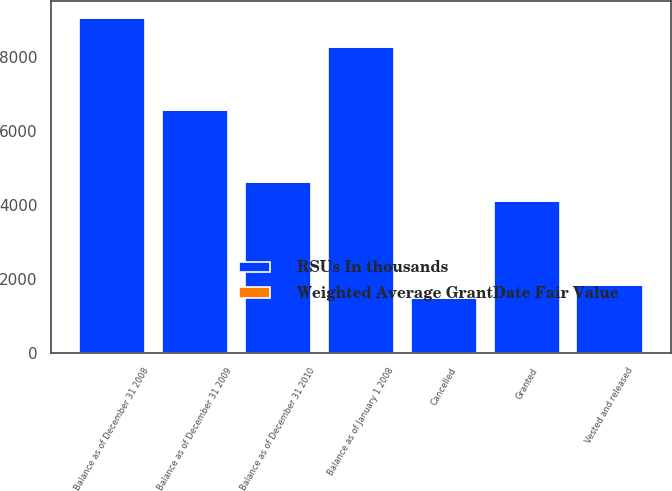<chart> <loc_0><loc_0><loc_500><loc_500><stacked_bar_chart><ecel><fcel>Balance as of January 1 2008<fcel>Granted<fcel>Vested and released<fcel>Cancelled<fcel>Balance as of December 31 2008<fcel>Balance as of December 31 2009<fcel>Balance as of December 31 2010<nl><fcel>RSUs In thousands<fcel>8262<fcel>4123<fcel>1846<fcel>1493<fcel>9046<fcel>6565<fcel>4633<nl><fcel>Weighted Average GrantDate Fair Value<fcel>21.43<fcel>21.78<fcel>21.76<fcel>22.2<fcel>21.41<fcel>19.5<fcel>20.12<nl></chart> 